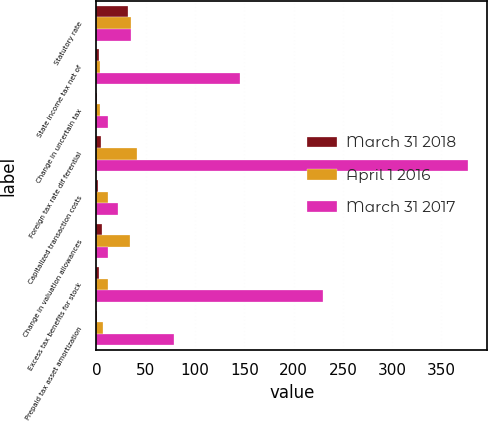Convert chart to OTSL. <chart><loc_0><loc_0><loc_500><loc_500><stacked_bar_chart><ecel><fcel>Statutory rate<fcel>State income tax net of<fcel>Change in uncertain tax<fcel>Foreign tax rate dif ferential<fcel>Capitalized transaction costs<fcel>Change in valuation allowances<fcel>Excess tax benefits for stock<fcel>Prepaid tax asset amortization<nl><fcel>March 31 2018<fcel>31.5<fcel>2.5<fcel>0.1<fcel>4.5<fcel>1.1<fcel>6<fcel>2.3<fcel>0.3<nl><fcel>April 1 2016<fcel>35<fcel>4<fcel>3.4<fcel>41.1<fcel>12.1<fcel>34.3<fcel>11.3<fcel>7.1<nl><fcel>March 31 2017<fcel>35<fcel>145.7<fcel>11.7<fcel>377.4<fcel>22.3<fcel>11.7<fcel>230<fcel>78.8<nl></chart> 